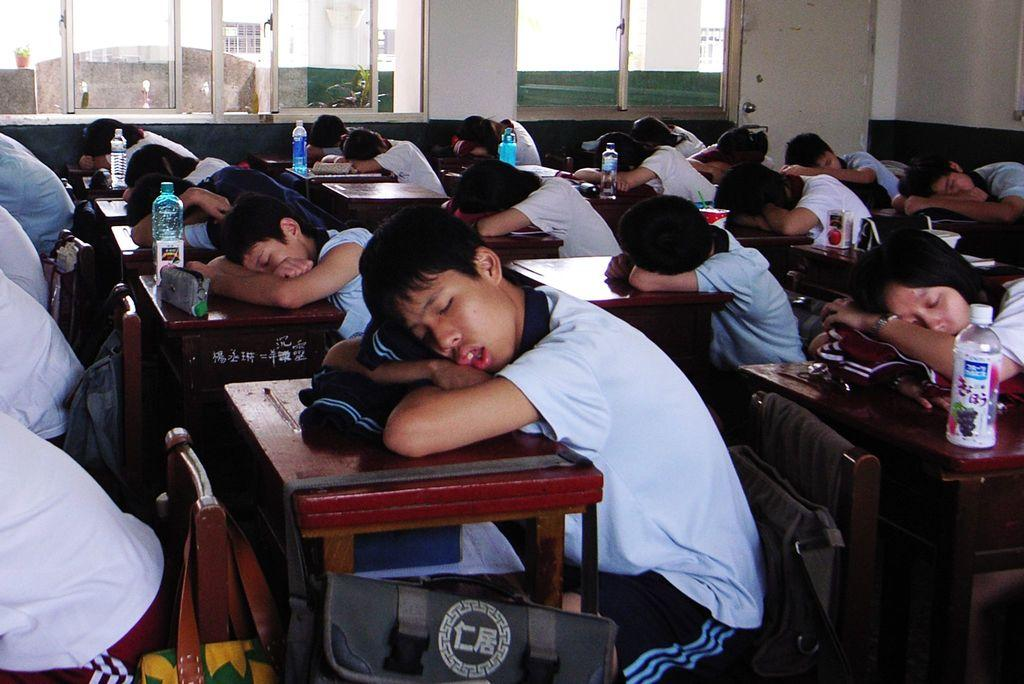How many people are in the image? There is a group of people in the image. What are the people doing in the image? The people are sitting on chairs. What is on the table in the image? There is a bottle, a box, and a bag on the table. What is visible in the background of the image? There is a window and a curtain associated with the window in the background of the image. What type of government is depicted in the image? There is no depiction of a government in the image; it features a group of people sitting on chairs with a table and various objects. 